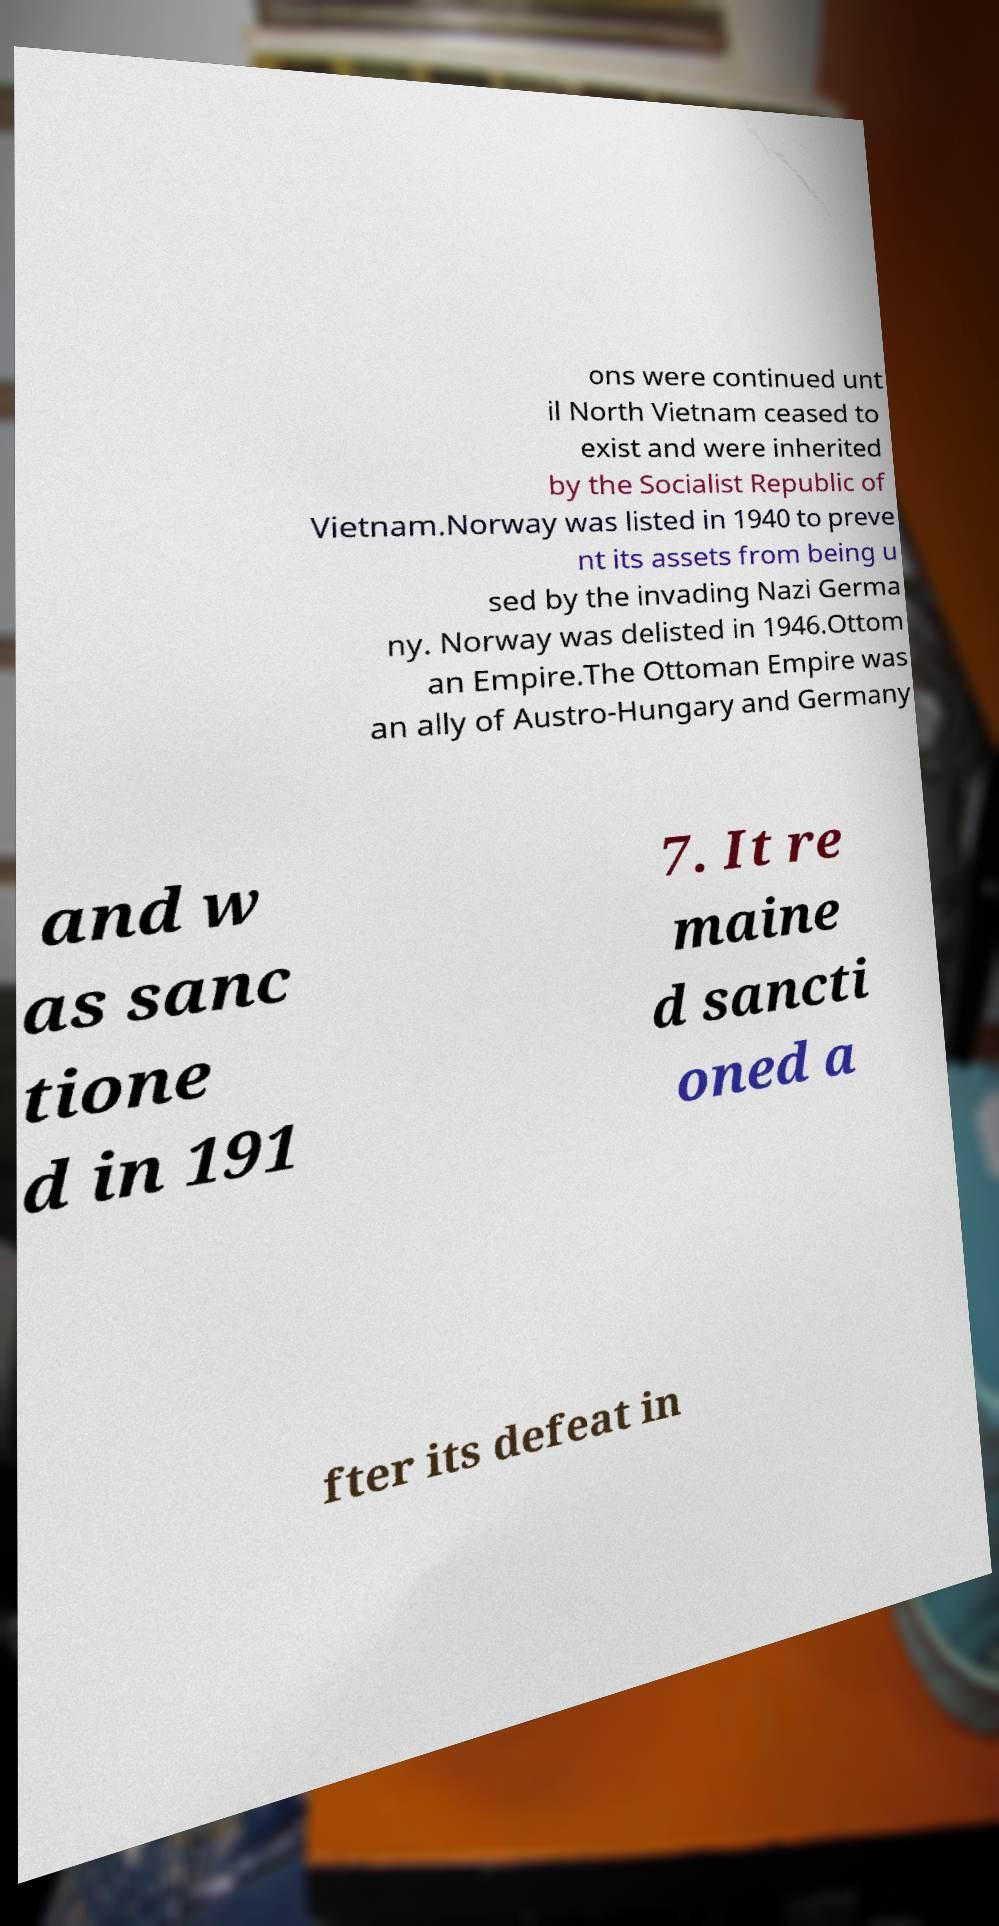Could you extract and type out the text from this image? ons were continued unt il North Vietnam ceased to exist and were inherited by the Socialist Republic of Vietnam.Norway was listed in 1940 to preve nt its assets from being u sed by the invading Nazi Germa ny. Norway was delisted in 1946.Ottom an Empire.The Ottoman Empire was an ally of Austro-Hungary and Germany and w as sanc tione d in 191 7. It re maine d sancti oned a fter its defeat in 